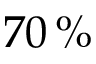Convert formula to latex. <formula><loc_0><loc_0><loc_500><loc_500>7 0 \, \%</formula> 